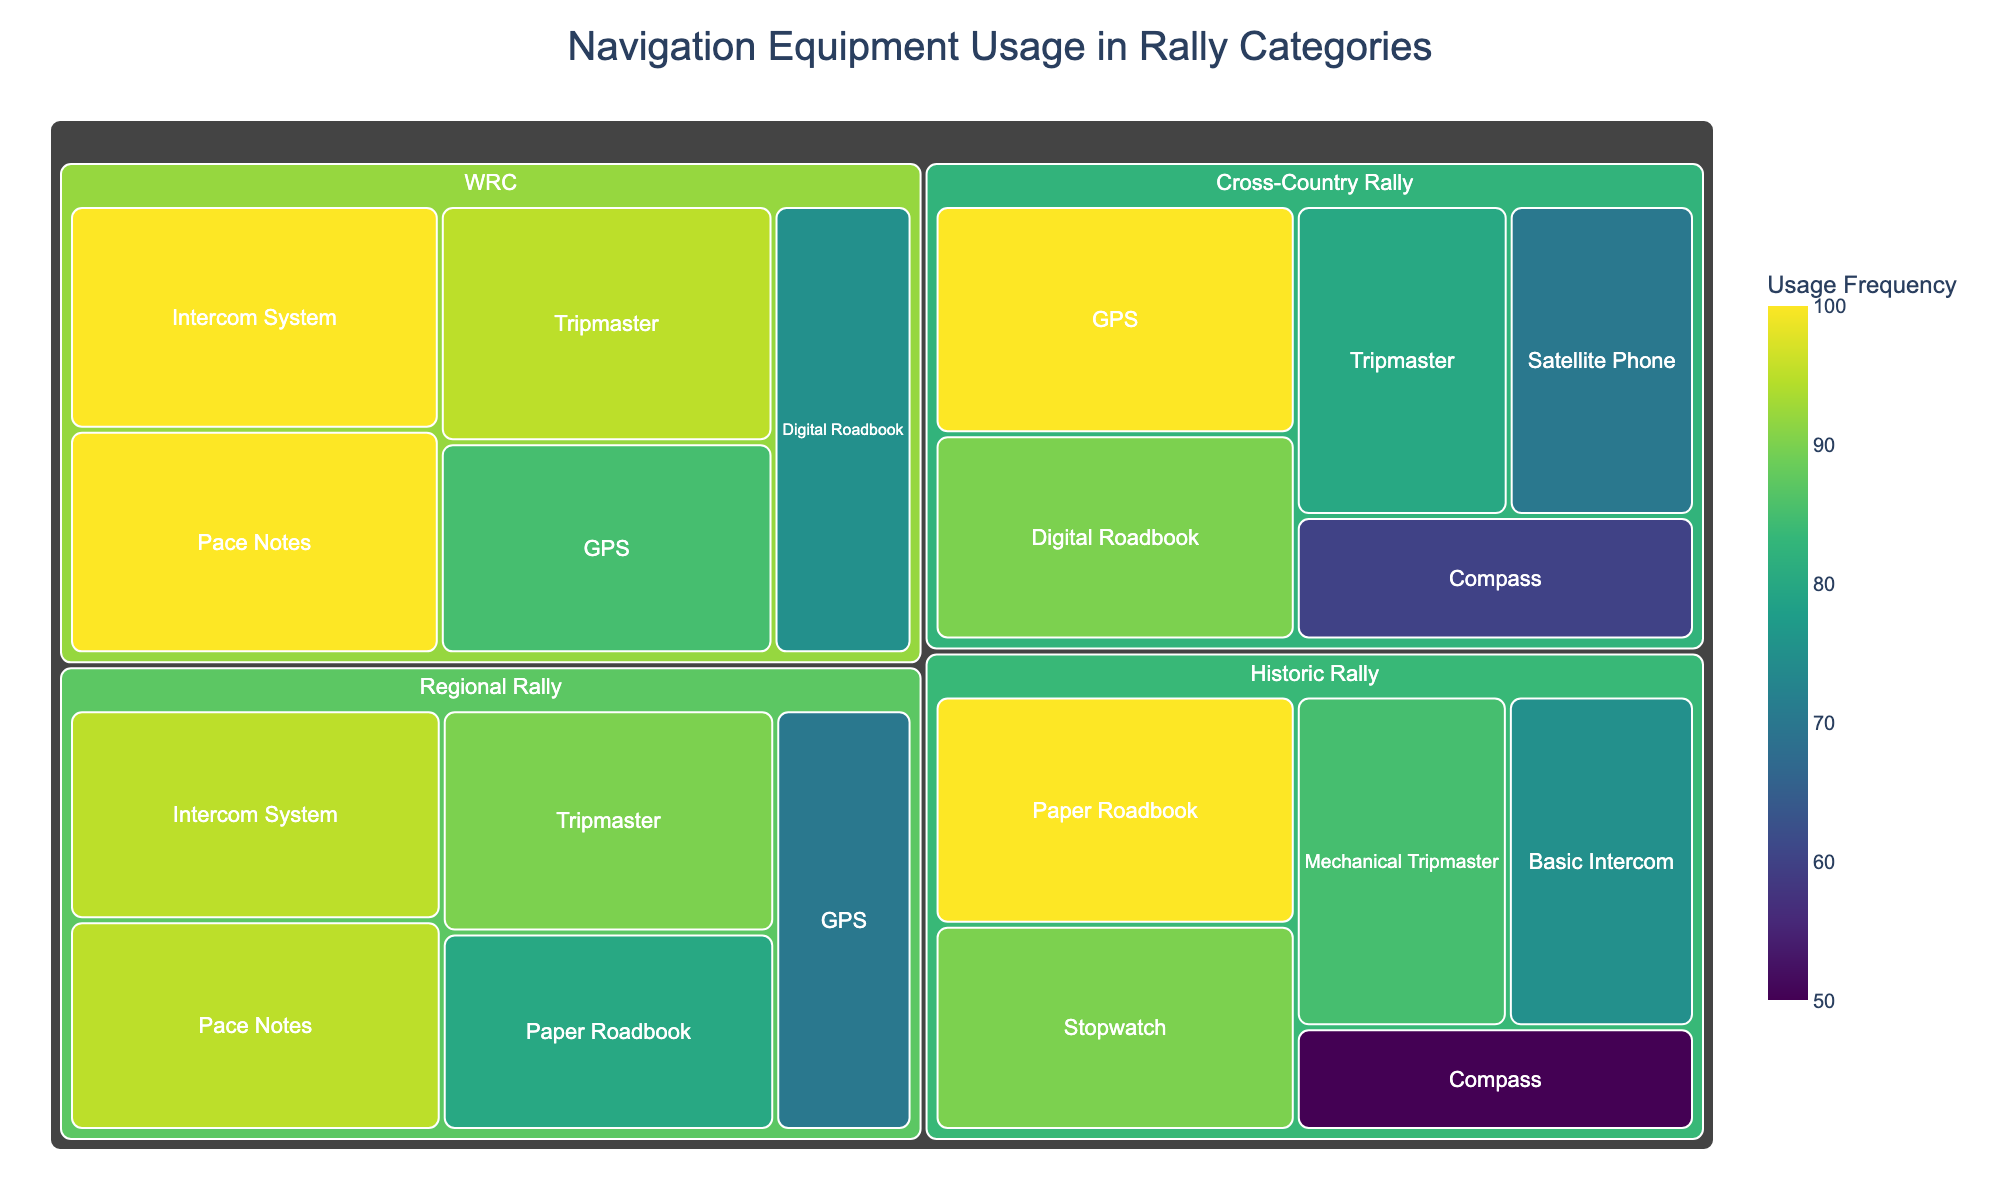What is the title of the treemap? The title of a plot is usually displayed at the top of the figure, providing a brief description of what the plot represents.
Answer: Navigation Equipment Usage in Rally Categories Which equipment type has the highest usage frequency in the 'WRC' category? Look at the WRC category section in the treemap to identify the equipment type with usage frequency at its maximum value. In this case, Tripmaster and Intercom System both have 100% usage frequency.
Answer: Tripmaster and Intercom System Among 'Regional Rally' equipment types, which one has the lowest usage frequency? Scan the 'Regional Rally' section of the treemap and find the equipment type with the smallest usage frequency percentage displayed.
Answer: GPS What is the total usage frequency of 'Compass' across all categories? Add the usage frequencies of Compass in each category where it appears (Cross-Country Rally: 60, Historic Rally: 50).
Answer: 110 Compare the usage frequency of 'Digital Roadbook' between 'WRC' and 'Cross-Country Rally'. Which category uses it more frequently? Find the usage frequency percentage for 'Digital Roadbook' under both 'WRC' and 'Cross-Country Rally' categories. The higher value indicates which category uses it more frequently.
Answer: Cross-Country Rally What's the average usage frequency of equipment in the 'Historic Rally' category? Sum the usage frequencies of each piece of equipment in the 'Historic Rally' category and then divide by the number of equipment types to find the average.
((85+100+90+50+75)/5)=80
Answer: 80 Which category uses 'GPS' the most frequently, and what is its percentage? Check the 'GPS' usage frequency across all categories and identify the category with the highest usage frequency for 'GPS'.
Answer: Cross-Country Rally, 100 How does the usage frequency of 'Mechanical Tripmaster' in 'Historic Rally' compare with 'Tripmaster' in 'Regional Rally'? Look at both categories and equipment in question, and then compare their usage frequencies to see which one is higher or if they are equal.
Answer: Regional Rally, 90% > Historic Rally, 85% What is the least used equipment type in the 'Cross-Country Rally' category? Identify the equipment type under the 'Cross-Country Rally' category that has the lowest usage frequency percentage.
Answer: Compass Is 'Intercom System' in 'WRC' used more frequently than 'Basic Intercom' in 'Historic Rally'? Compare the usage frequency of 'Intercom System' in the WRC category with 'Basic Intercom' in the Historic Rally category to determine which is used more frequently.
Answer: Yes, 100% vs. 75% 